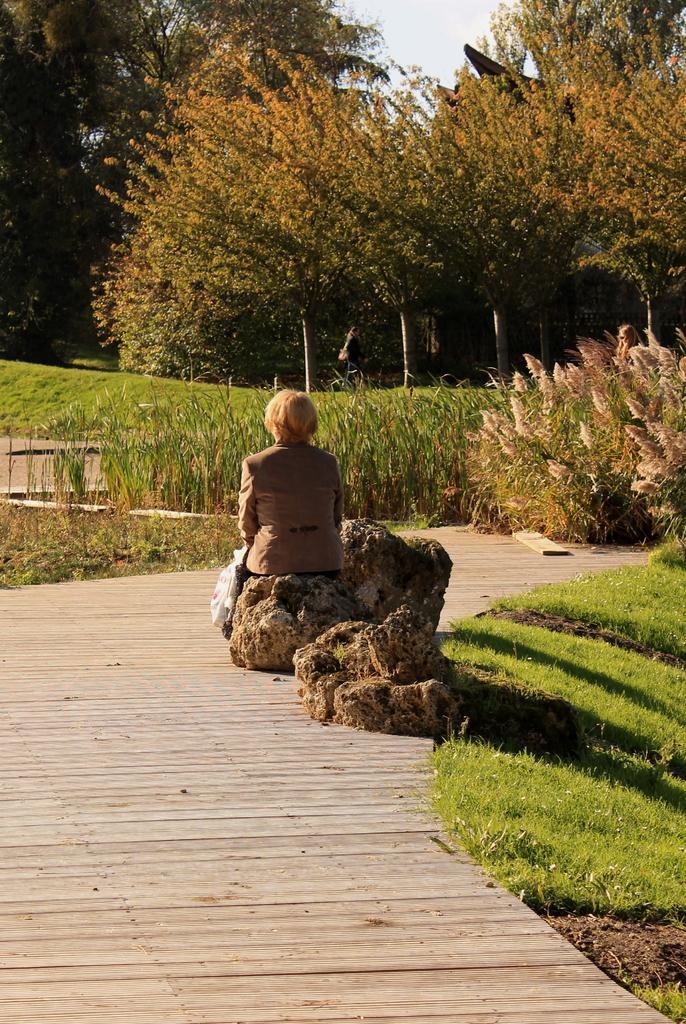Please provide a concise description of this image. In the picture we can see woman wearing brown color dress sitting on stone, there is walkway and in the background of the picture there are some plants, trees and there is clear sky. 